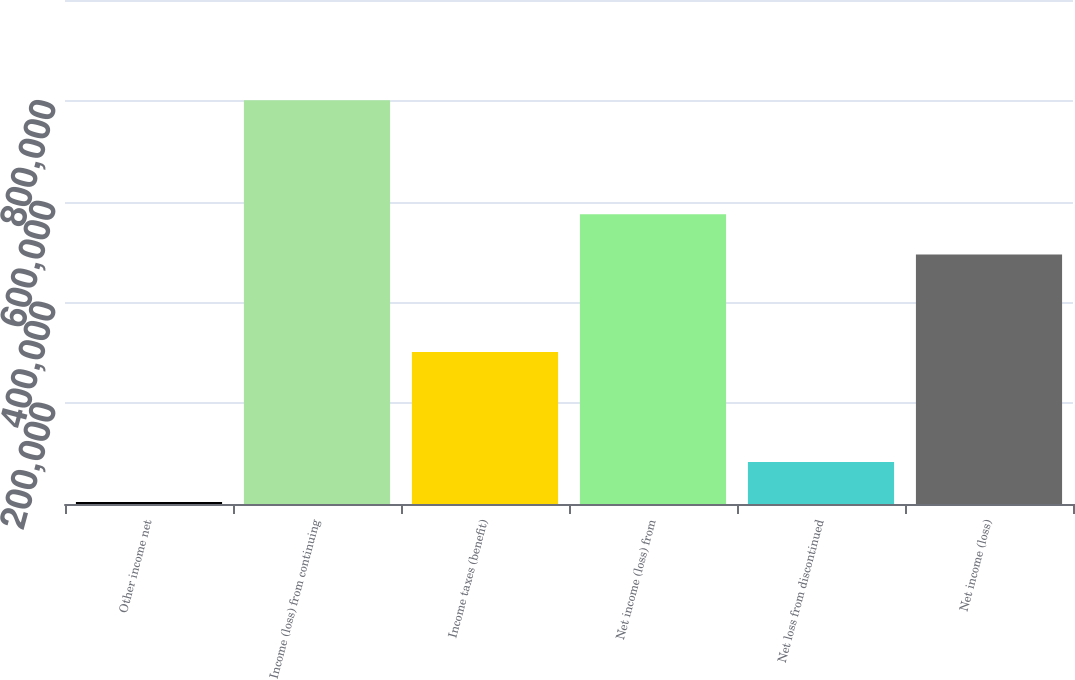<chart> <loc_0><loc_0><loc_500><loc_500><bar_chart><fcel>Other income net<fcel>Income (loss) from continuing<fcel>Income taxes (benefit)<fcel>Net income (loss) from<fcel>Net loss from discontinued<fcel>Net income (loss)<nl><fcel>3771<fcel>800978<fcel>301557<fcel>574714<fcel>83491.7<fcel>494993<nl></chart> 